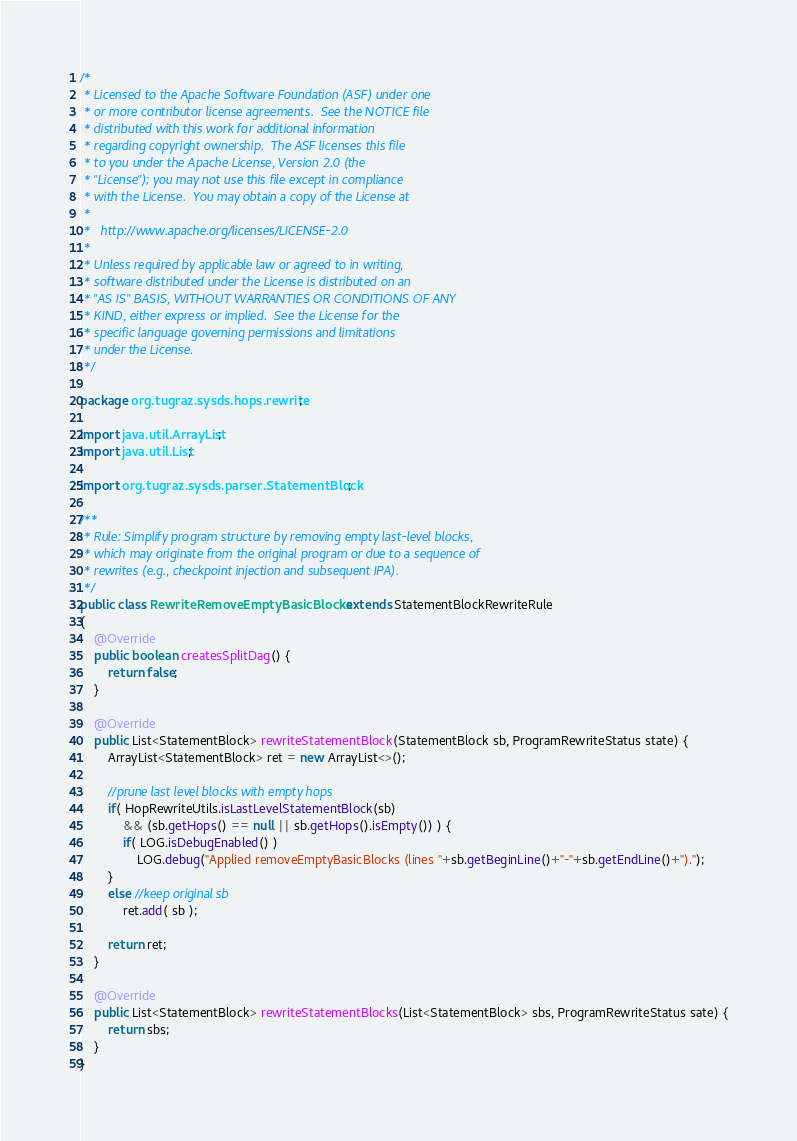<code> <loc_0><loc_0><loc_500><loc_500><_Java_>/*
 * Licensed to the Apache Software Foundation (ASF) under one
 * or more contributor license agreements.  See the NOTICE file
 * distributed with this work for additional information
 * regarding copyright ownership.  The ASF licenses this file
 * to you under the Apache License, Version 2.0 (the
 * "License"); you may not use this file except in compliance
 * with the License.  You may obtain a copy of the License at
 * 
 *   http://www.apache.org/licenses/LICENSE-2.0
 * 
 * Unless required by applicable law or agreed to in writing,
 * software distributed under the License is distributed on an
 * "AS IS" BASIS, WITHOUT WARRANTIES OR CONDITIONS OF ANY
 * KIND, either express or implied.  See the License for the
 * specific language governing permissions and limitations
 * under the License.
 */

package org.tugraz.sysds.hops.rewrite;

import java.util.ArrayList;
import java.util.List;

import org.tugraz.sysds.parser.StatementBlock;

/**
 * Rule: Simplify program structure by removing empty last-level blocks,
 * which may originate from the original program or due to a sequence of
 * rewrites (e.g., checkpoint injection and subsequent IPA).
 */
public class RewriteRemoveEmptyBasicBlocks extends StatementBlockRewriteRule
{
	@Override
	public boolean createsSplitDag() {
		return false;
	}
	
	@Override
	public List<StatementBlock> rewriteStatementBlock(StatementBlock sb, ProgramRewriteStatus state) {
		ArrayList<StatementBlock> ret = new ArrayList<>();
		
		//prune last level blocks with empty hops
		if( HopRewriteUtils.isLastLevelStatementBlock(sb)
			&& (sb.getHops() == null || sb.getHops().isEmpty()) ) {
			if( LOG.isDebugEnabled() )
				LOG.debug("Applied removeEmptyBasicBlocks (lines "+sb.getBeginLine()+"-"+sb.getEndLine()+").");
		}
		else //keep original sb
			ret.add( sb );
		
		return ret;
	}
	
	@Override
	public List<StatementBlock> rewriteStatementBlocks(List<StatementBlock> sbs, ProgramRewriteStatus sate) {
		return sbs;
	}
}
</code> 